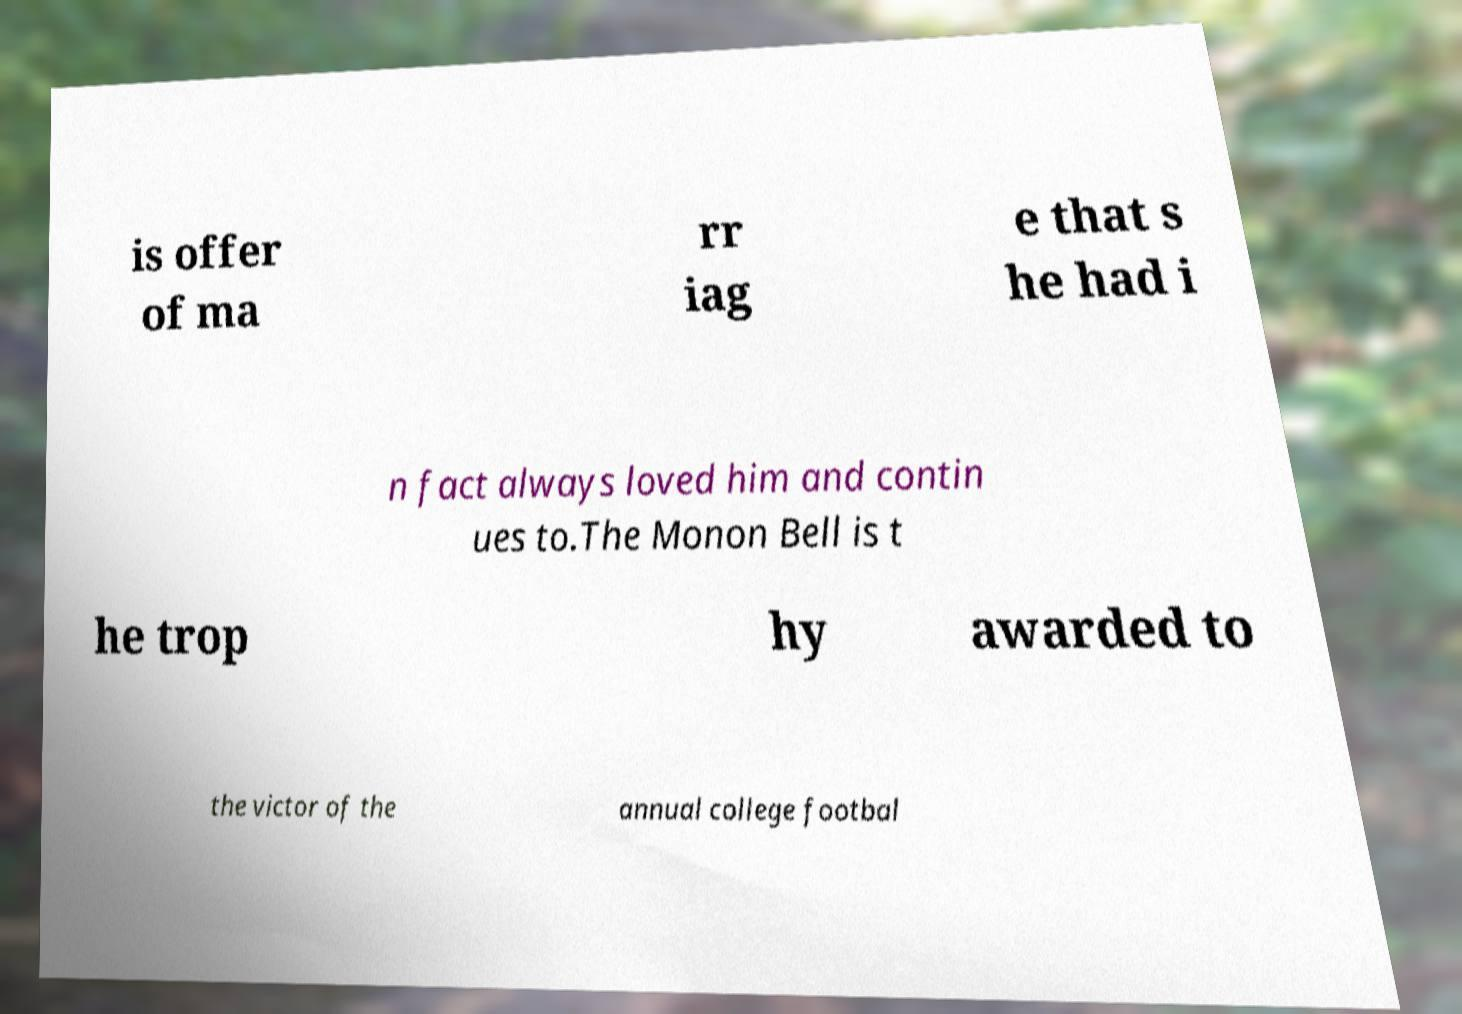I need the written content from this picture converted into text. Can you do that? is offer of ma rr iag e that s he had i n fact always loved him and contin ues to.The Monon Bell is t he trop hy awarded to the victor of the annual college footbal 